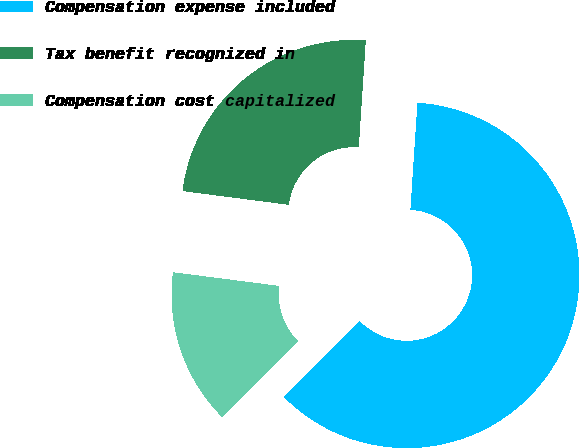Convert chart. <chart><loc_0><loc_0><loc_500><loc_500><pie_chart><fcel>Compensation expense included<fcel>Tax benefit recognized in<fcel>Compensation cost capitalized<nl><fcel>61.5%<fcel>24.0%<fcel>14.5%<nl></chart> 